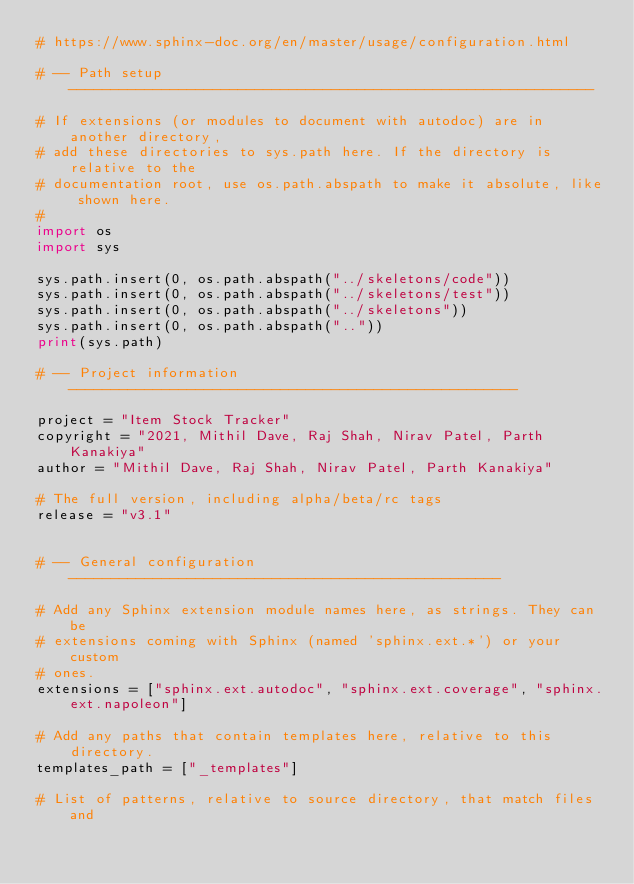<code> <loc_0><loc_0><loc_500><loc_500><_Python_># https://www.sphinx-doc.org/en/master/usage/configuration.html

# -- Path setup --------------------------------------------------------------

# If extensions (or modules to document with autodoc) are in another directory,
# add these directories to sys.path here. If the directory is relative to the
# documentation root, use os.path.abspath to make it absolute, like shown here.
#
import os
import sys

sys.path.insert(0, os.path.abspath("../skeletons/code"))
sys.path.insert(0, os.path.abspath("../skeletons/test"))
sys.path.insert(0, os.path.abspath("../skeletons"))
sys.path.insert(0, os.path.abspath(".."))
print(sys.path)

# -- Project information -----------------------------------------------------

project = "Item Stock Tracker"
copyright = "2021, Mithil Dave, Raj Shah, Nirav Patel, Parth Kanakiya"
author = "Mithil Dave, Raj Shah, Nirav Patel, Parth Kanakiya"

# The full version, including alpha/beta/rc tags
release = "v3.1"


# -- General configuration ---------------------------------------------------

# Add any Sphinx extension module names here, as strings. They can be
# extensions coming with Sphinx (named 'sphinx.ext.*') or your custom
# ones.
extensions = ["sphinx.ext.autodoc", "sphinx.ext.coverage", "sphinx.ext.napoleon"]

# Add any paths that contain templates here, relative to this directory.
templates_path = ["_templates"]

# List of patterns, relative to source directory, that match files and</code> 